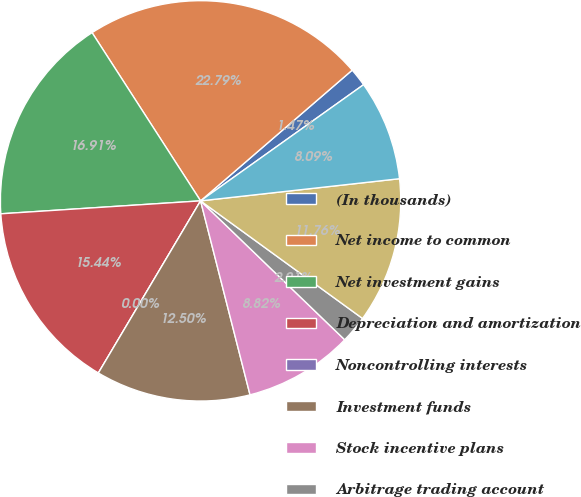Convert chart. <chart><loc_0><loc_0><loc_500><loc_500><pie_chart><fcel>(In thousands)<fcel>Net income to common<fcel>Net investment gains<fcel>Depreciation and amortization<fcel>Noncontrolling interests<fcel>Investment funds<fcel>Stock incentive plans<fcel>Arbitrage trading account<fcel>Premiums and fees receivable<fcel>Reinsurance accounts<nl><fcel>1.47%<fcel>22.79%<fcel>16.91%<fcel>15.44%<fcel>0.0%<fcel>12.5%<fcel>8.82%<fcel>2.21%<fcel>11.76%<fcel>8.09%<nl></chart> 